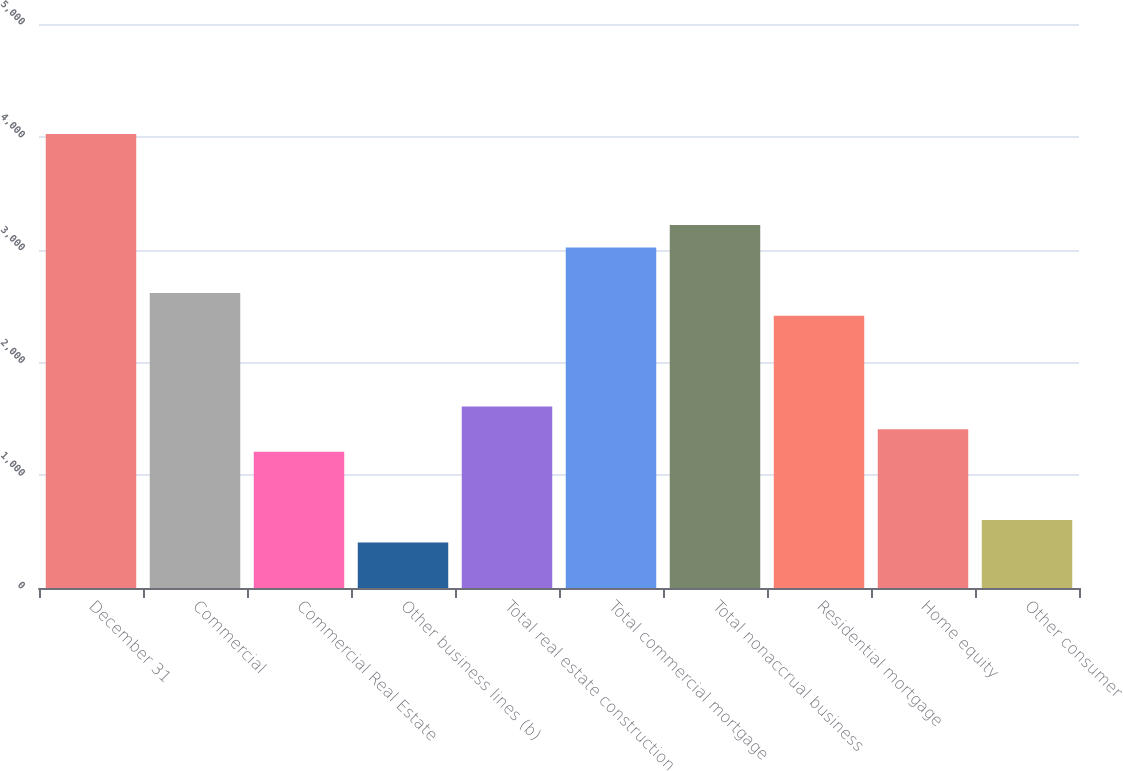Convert chart. <chart><loc_0><loc_0><loc_500><loc_500><bar_chart><fcel>December 31<fcel>Commercial<fcel>Commercial Real Estate<fcel>Other business lines (b)<fcel>Total real estate construction<fcel>Total commercial mortgage<fcel>Total nonaccrual business<fcel>Residential mortgage<fcel>Home equity<fcel>Other consumer<nl><fcel>4023.98<fcel>2615.59<fcel>1207.23<fcel>402.45<fcel>1609.62<fcel>3017.99<fcel>3219.18<fcel>2414.39<fcel>1408.42<fcel>603.64<nl></chart> 